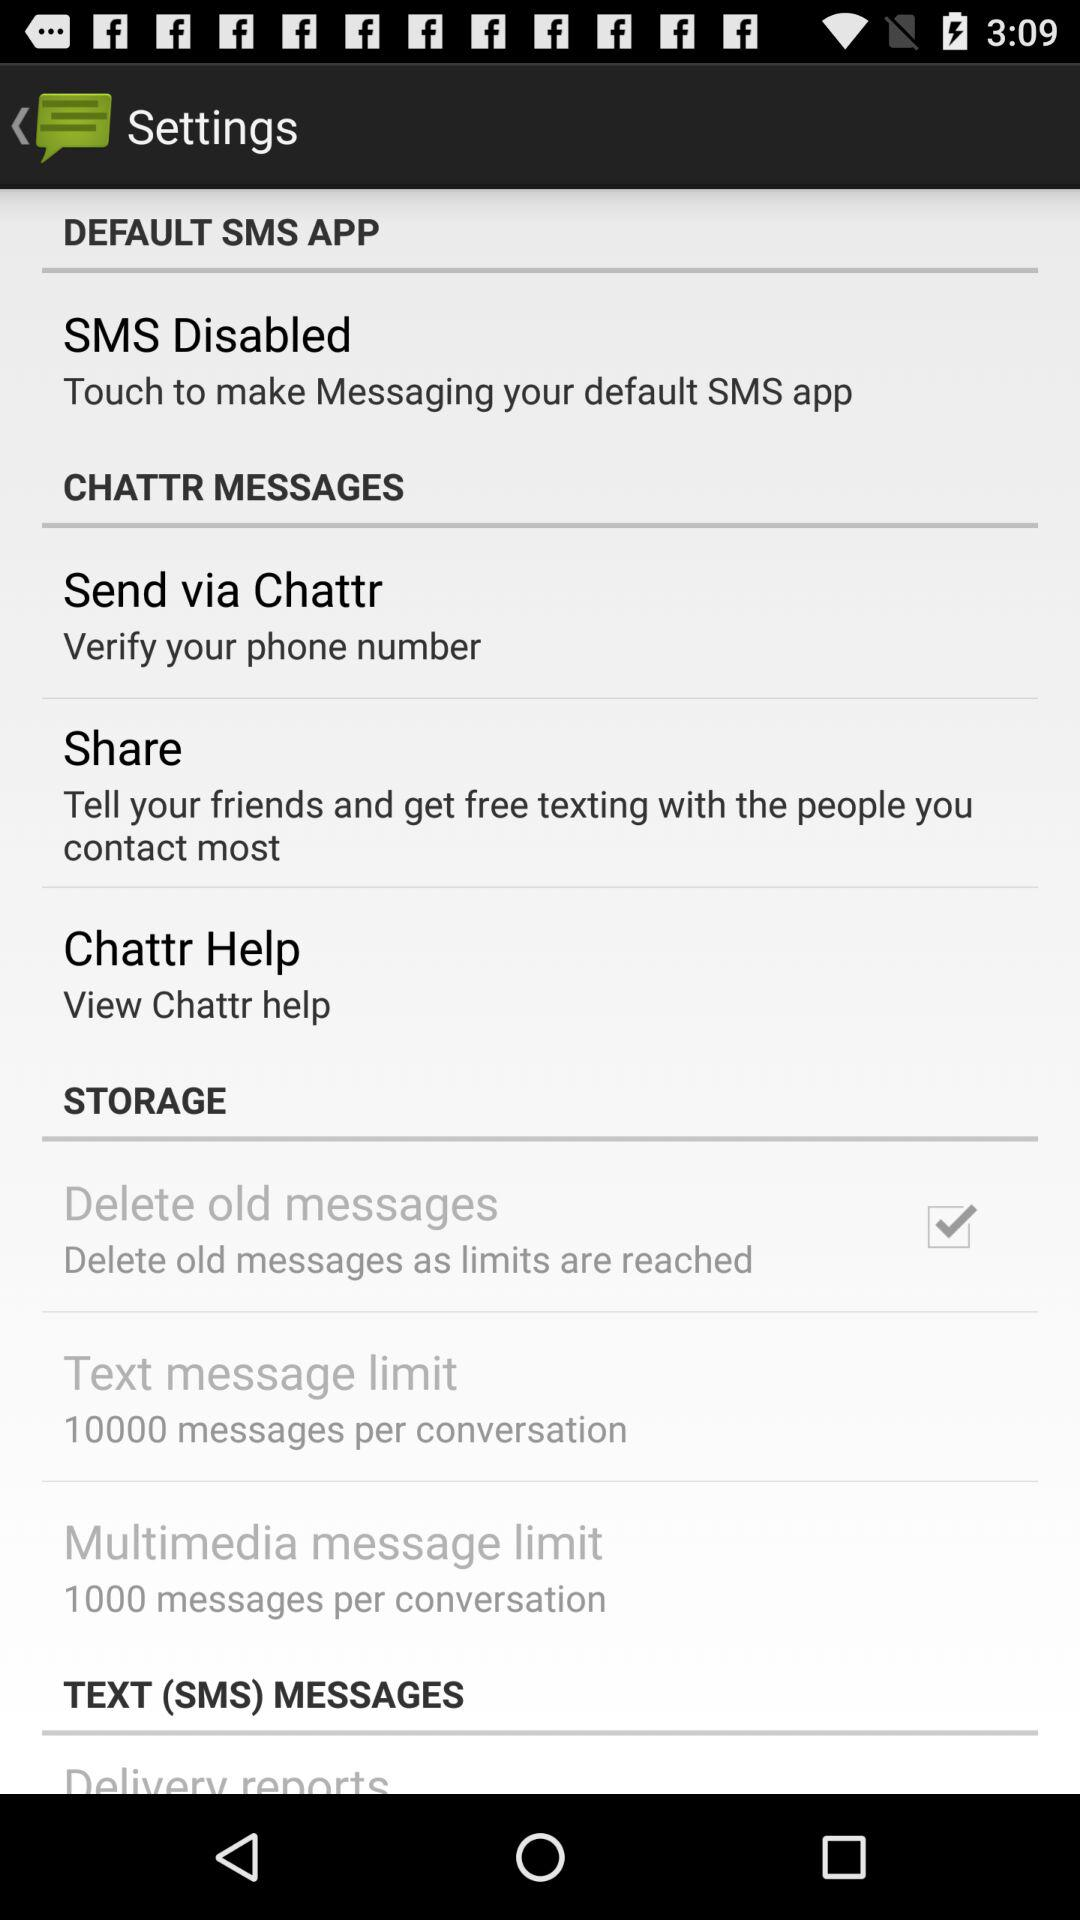What is the text message limit? The text message limit is "10000 messages per conversation". 